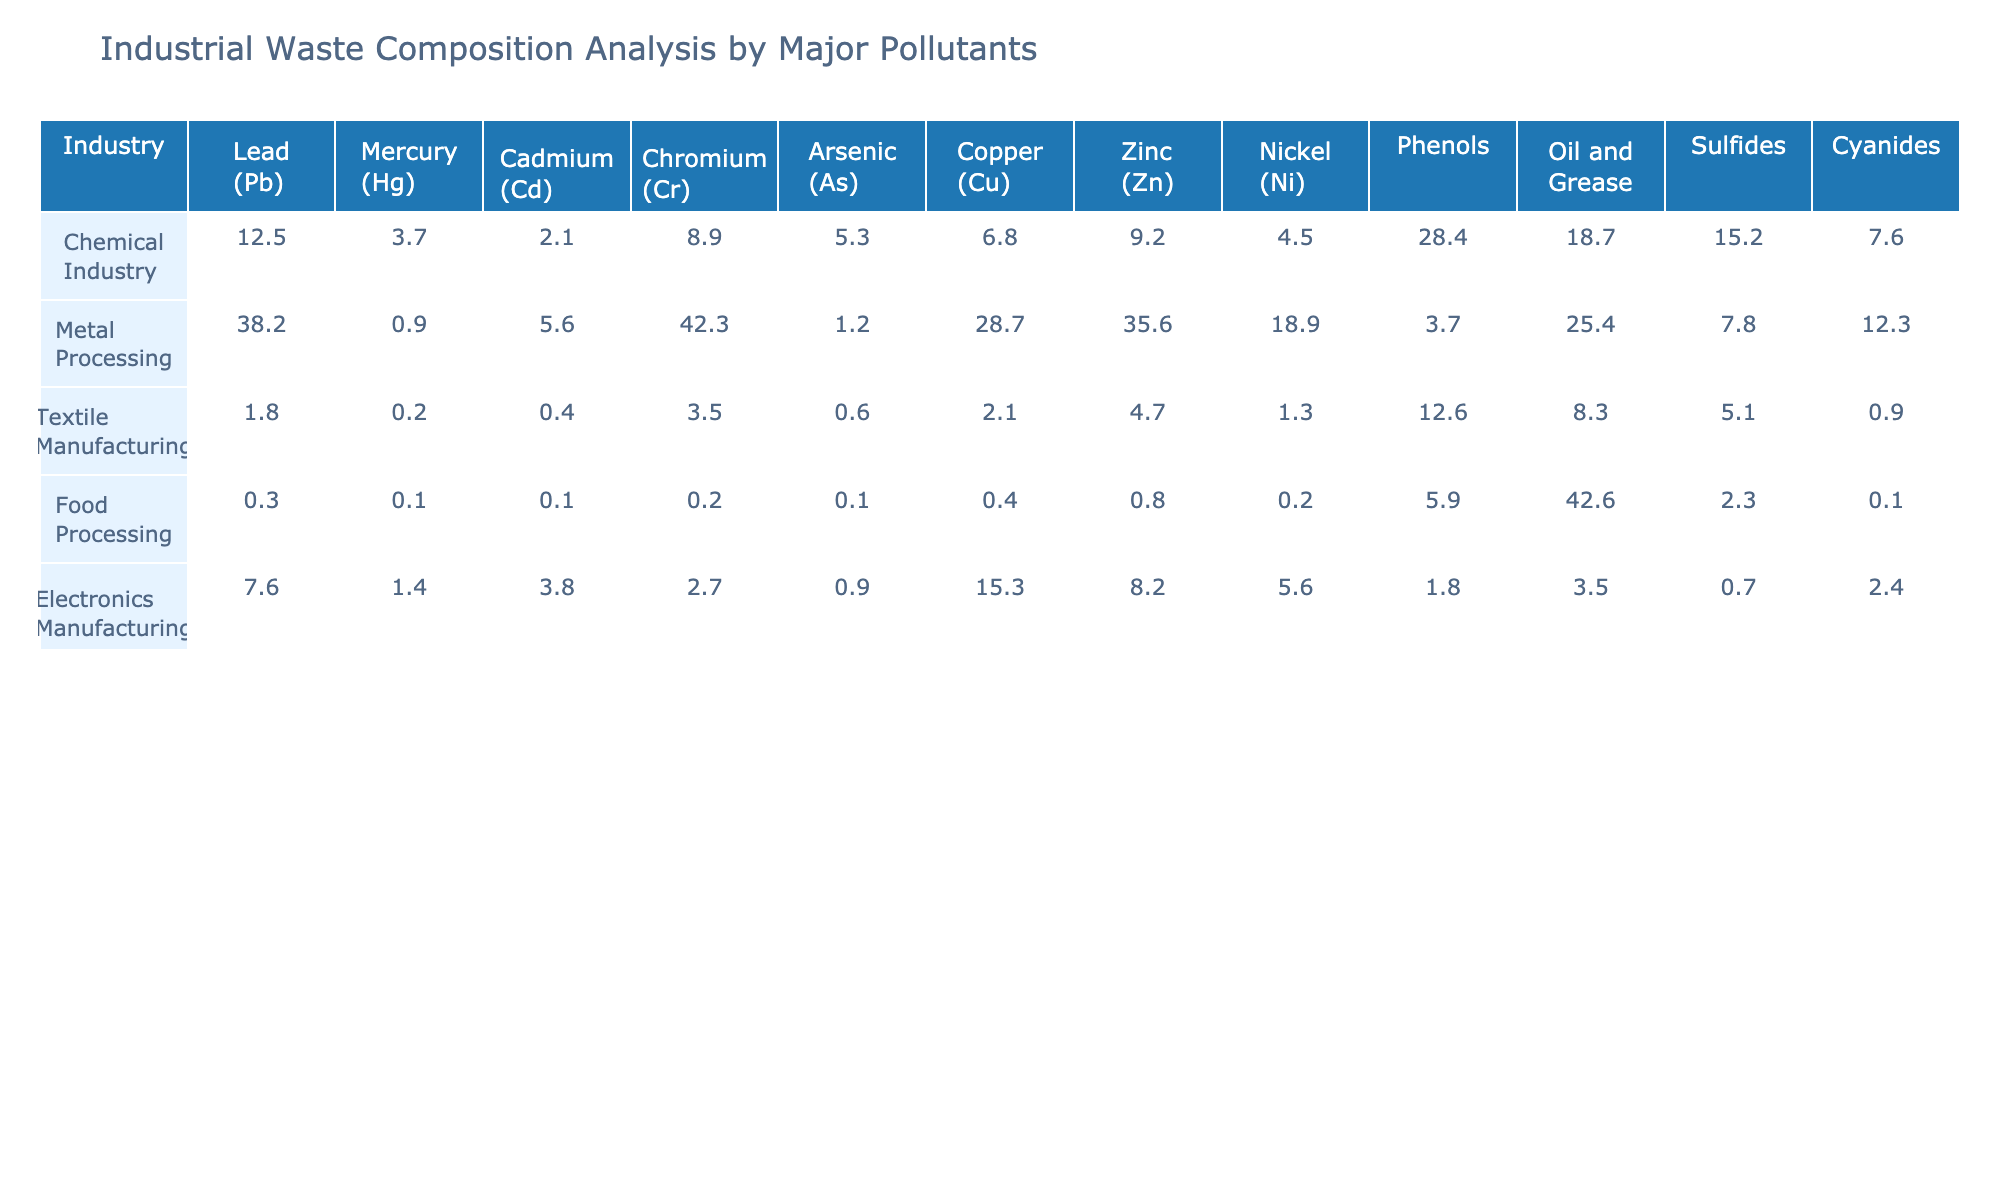What is the highest level of lead pollution among the industries listed? Looking at the table, the highest level of lead pollution is found in the Metal Processing industry, which has a value of 38.2.
Answer: 38.2 Which industry has the lowest amount of mercury pollution? Upon examining the table, the industry with the lowest amount of mercury pollution is the Textile Manufacturing industry, with a value of 0.2.
Answer: 0.2 What is the total amount of cadmium pollution from the Chemical Industry and Electronics Manufacturing combined? To find the total amount of cadmium pollution from both industries, we add the values: Chemical Industry (2.1) + Electronics Manufacturing (3.8) = 5.9.
Answer: 5.9 Is the amount of chromatic pollution in Food Processing higher than in Electronics Manufacturing? By comparing the values, Food Processing has 0.2 for chromium, while Electronics Manufacturing has 2.7. Therefore, Food Processing does not have higher pollution than Electronics Manufacturing.
Answer: No What is the average amount of oil and grease pollution across all industries? To find the average, we first sum the values of oil and grease pollution: 18.7 + 25.4 + 8.3 + 42.6 + 3.5 = 98.5. Then, we divide by the number of industries (5): 98.5 / 5 = 19.7.
Answer: 19.7 Which industrial sector shows the highest pollution level for phenols, and what is that value? After reviewing the table, the Chemical Industry has the highest pollution level for phenols, which is 28.4.
Answer: 28.4 How does the zinc pollution in the Metal Processing industry compare to the Food Processing industry? The Metal Processing industry reports 35.6 for zinc pollution, while the Food Processing industry has only 0.8. Thus, Metal Processing has a significantly higher amount of pollution.
Answer: Metal Processing has more What is the difference in nickel pollution levels between Textile Manufacturing and Electronics Manufacturing? For this, we subtract the values: Electronics Manufacturing (5.6) - Textile Manufacturing (1.3) = 4.3.
Answer: 4.3 Which pollutant has the highest average concentration across all industries? To determine this, we calculate the average for each pollutant and compare. The highest average, notably for oil and grease, is 19.7 (previously calculated).
Answer: Oil and grease If you combine the total amounts of cadmium and arsenic pollution from all industrial sectors, what is the sum? First, we add the values: 2.1 (cadmium in Chemical) + 5.6 (cadmium in Metal) + 0.4 (cadmium in Textile) + 0.1 (cadmium in Food) + 3.8 (cadmium in Electronics) = 12.0. Then for arsenic: 5.3 + 1.2 + 0.6 + 0.1 + 0.9 = 8.1. The total sum is 12.0 + 8.1 = 20.1.
Answer: 20.1 